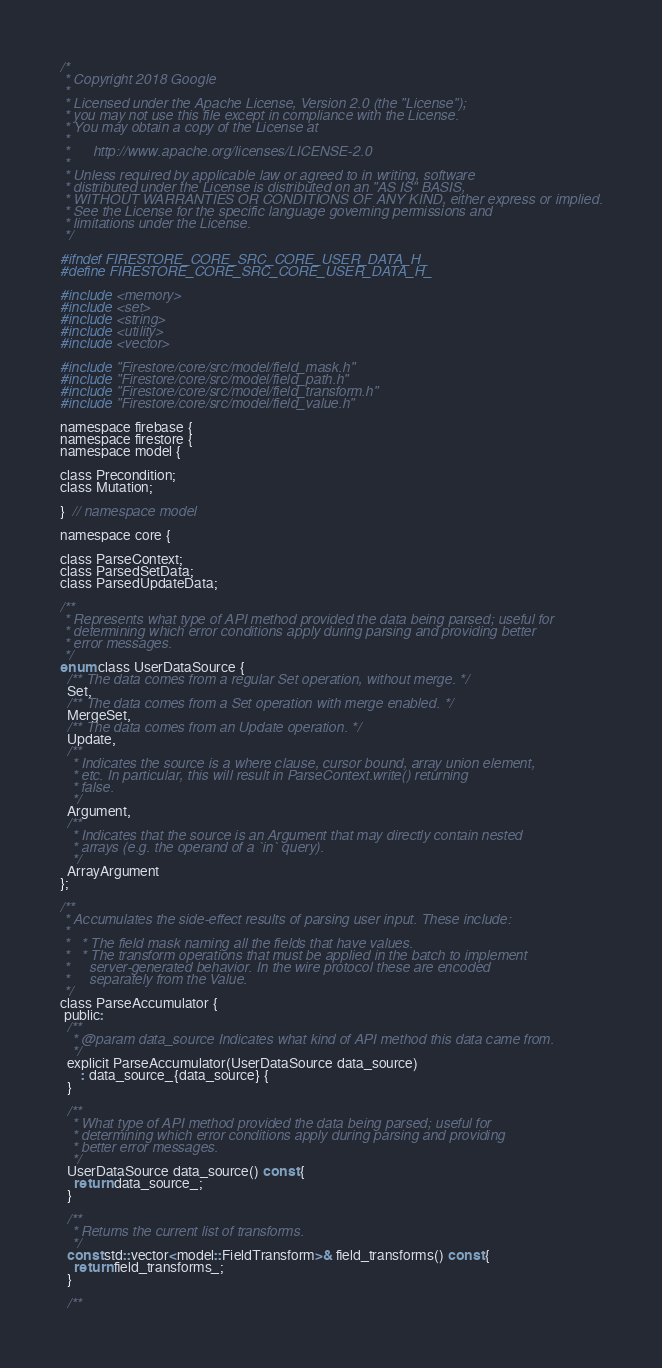<code> <loc_0><loc_0><loc_500><loc_500><_C_>/*
 * Copyright 2018 Google
 *
 * Licensed under the Apache License, Version 2.0 (the "License");
 * you may not use this file except in compliance with the License.
 * You may obtain a copy of the License at
 *
 *      http://www.apache.org/licenses/LICENSE-2.0
 *
 * Unless required by applicable law or agreed to in writing, software
 * distributed under the License is distributed on an "AS IS" BASIS,
 * WITHOUT WARRANTIES OR CONDITIONS OF ANY KIND, either express or implied.
 * See the License for the specific language governing permissions and
 * limitations under the License.
 */

#ifndef FIRESTORE_CORE_SRC_CORE_USER_DATA_H_
#define FIRESTORE_CORE_SRC_CORE_USER_DATA_H_

#include <memory>
#include <set>
#include <string>
#include <utility>
#include <vector>

#include "Firestore/core/src/model/field_mask.h"
#include "Firestore/core/src/model/field_path.h"
#include "Firestore/core/src/model/field_transform.h"
#include "Firestore/core/src/model/field_value.h"

namespace firebase {
namespace firestore {
namespace model {

class Precondition;
class Mutation;

}  // namespace model

namespace core {

class ParseContext;
class ParsedSetData;
class ParsedUpdateData;

/**
 * Represents what type of API method provided the data being parsed; useful for
 * determining which error conditions apply during parsing and providing better
 * error messages.
 */
enum class UserDataSource {
  /** The data comes from a regular Set operation, without merge. */
  Set,
  /** The data comes from a Set operation with merge enabled. */
  MergeSet,
  /** The data comes from an Update operation. */
  Update,
  /**
   * Indicates the source is a where clause, cursor bound, array union element,
   * etc. In particular, this will result in ParseContext.write() returning
   * false.
   */
  Argument,
  /**
   * Indicates that the source is an Argument that may directly contain nested
   * arrays (e.g. the operand of a `in` query).
   */
  ArrayArgument
};

/**
 * Accumulates the side-effect results of parsing user input. These include:
 *
 *   * The field mask naming all the fields that have values.
 *   * The transform operations that must be applied in the batch to implement
 *     server-generated behavior. In the wire protocol these are encoded
 *     separately from the Value.
 */
class ParseAccumulator {
 public:
  /**
   * @param data_source Indicates what kind of API method this data came from.
   */
  explicit ParseAccumulator(UserDataSource data_source)
      : data_source_{data_source} {
  }

  /**
   * What type of API method provided the data being parsed; useful for
   * determining which error conditions apply during parsing and providing
   * better error messages.
   */
  UserDataSource data_source() const {
    return data_source_;
  }

  /**
   * Returns the current list of transforms.
   */
  const std::vector<model::FieldTransform>& field_transforms() const {
    return field_transforms_;
  }

  /**</code> 